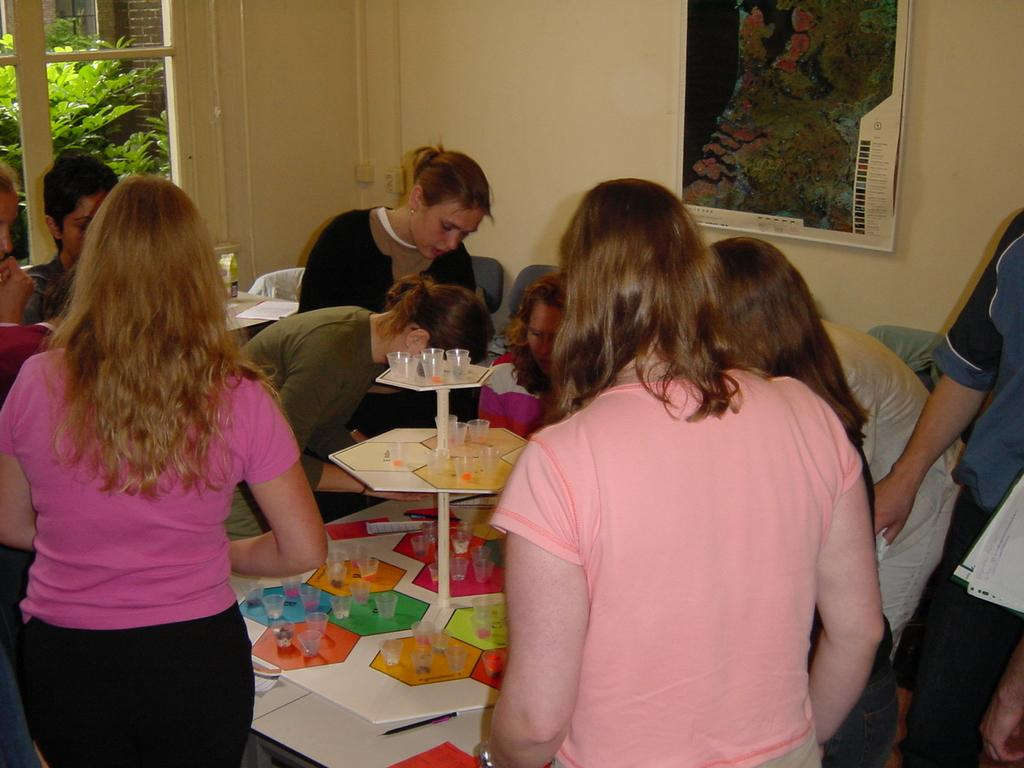What are the persons in the image doing? There are persons sitting on chairs and standing in the image. What objects can be seen on the table? There are glasses on the table. What can be seen in the background of the image? There is a wall, a window, and a frame in the background. What is visible through the window? Trees are visible through the window. What type of owl can be seen perched on the frame in the background? There is no owl present in the image; the frame in the background is empty. What kind of milk is being served in the glasses on the table? There is no milk visible in the glasses on the table; only glasses are mentioned. 